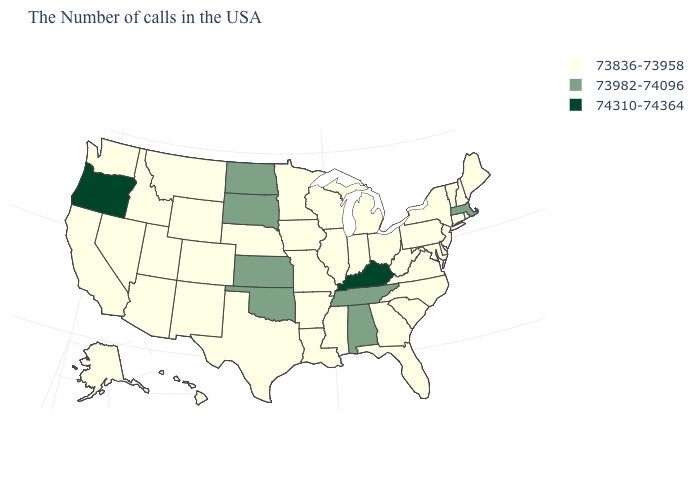What is the value of Tennessee?
Quick response, please. 73982-74096. How many symbols are there in the legend?
Write a very short answer. 3. What is the value of South Carolina?
Quick response, please. 73836-73958. Which states have the lowest value in the USA?
Concise answer only. Maine, Rhode Island, New Hampshire, Vermont, Connecticut, New York, New Jersey, Delaware, Maryland, Pennsylvania, Virginia, North Carolina, South Carolina, West Virginia, Ohio, Florida, Georgia, Michigan, Indiana, Wisconsin, Illinois, Mississippi, Louisiana, Missouri, Arkansas, Minnesota, Iowa, Nebraska, Texas, Wyoming, Colorado, New Mexico, Utah, Montana, Arizona, Idaho, Nevada, California, Washington, Alaska, Hawaii. What is the value of Arizona?
Answer briefly. 73836-73958. Which states hav the highest value in the South?
Short answer required. Kentucky. Does New Mexico have the same value as Alabama?
Keep it brief. No. What is the lowest value in the USA?
Answer briefly. 73836-73958. What is the value of Nebraska?
Give a very brief answer. 73836-73958. Is the legend a continuous bar?
Give a very brief answer. No. Among the states that border Florida , does Alabama have the lowest value?
Write a very short answer. No. Name the states that have a value in the range 73836-73958?
Be succinct. Maine, Rhode Island, New Hampshire, Vermont, Connecticut, New York, New Jersey, Delaware, Maryland, Pennsylvania, Virginia, North Carolina, South Carolina, West Virginia, Ohio, Florida, Georgia, Michigan, Indiana, Wisconsin, Illinois, Mississippi, Louisiana, Missouri, Arkansas, Minnesota, Iowa, Nebraska, Texas, Wyoming, Colorado, New Mexico, Utah, Montana, Arizona, Idaho, Nevada, California, Washington, Alaska, Hawaii. Does the first symbol in the legend represent the smallest category?
Concise answer only. Yes. Is the legend a continuous bar?
Answer briefly. No. Does Delaware have a higher value than Maryland?
Concise answer only. No. 